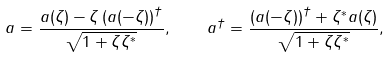Convert formula to latex. <formula><loc_0><loc_0><loc_500><loc_500>a = \frac { a ( \zeta ) - \zeta \left ( a ( - \zeta ) \right ) ^ { \dagger } } { \sqrt { 1 + \zeta \zeta ^ { * } } } , \quad a ^ { \dagger } = \frac { \left ( a ( - \zeta ) \right ) ^ { \dagger } + \zeta ^ { * } a ( \zeta ) } { \sqrt { 1 + \zeta \zeta ^ { * } } } ,</formula> 